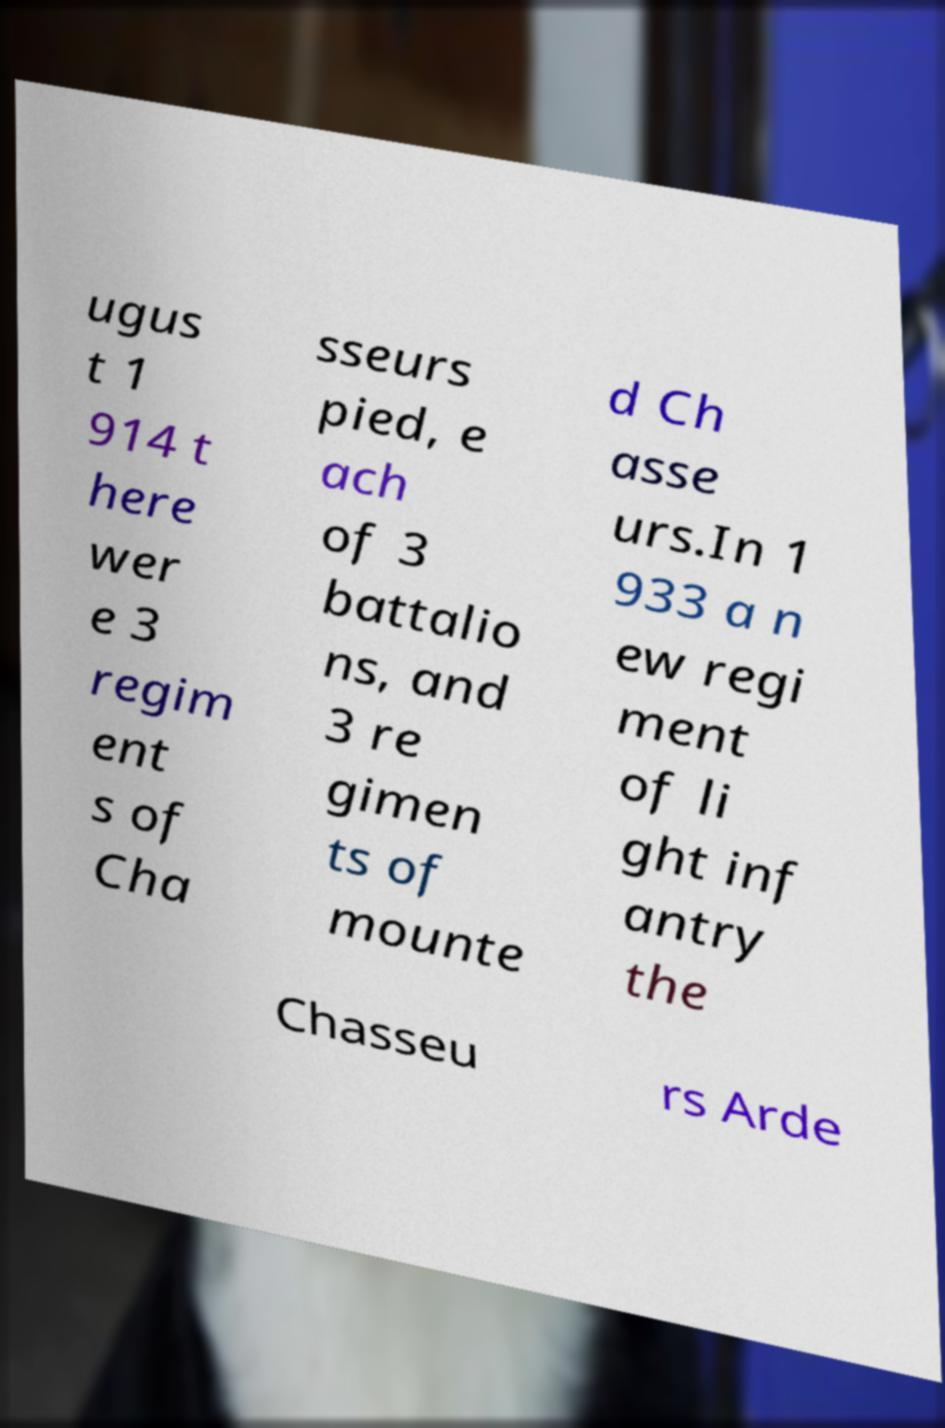Could you assist in decoding the text presented in this image and type it out clearly? ugus t 1 914 t here wer e 3 regim ent s of Cha sseurs pied, e ach of 3 battalio ns, and 3 re gimen ts of mounte d Ch asse urs.In 1 933 a n ew regi ment of li ght inf antry the Chasseu rs Arde 